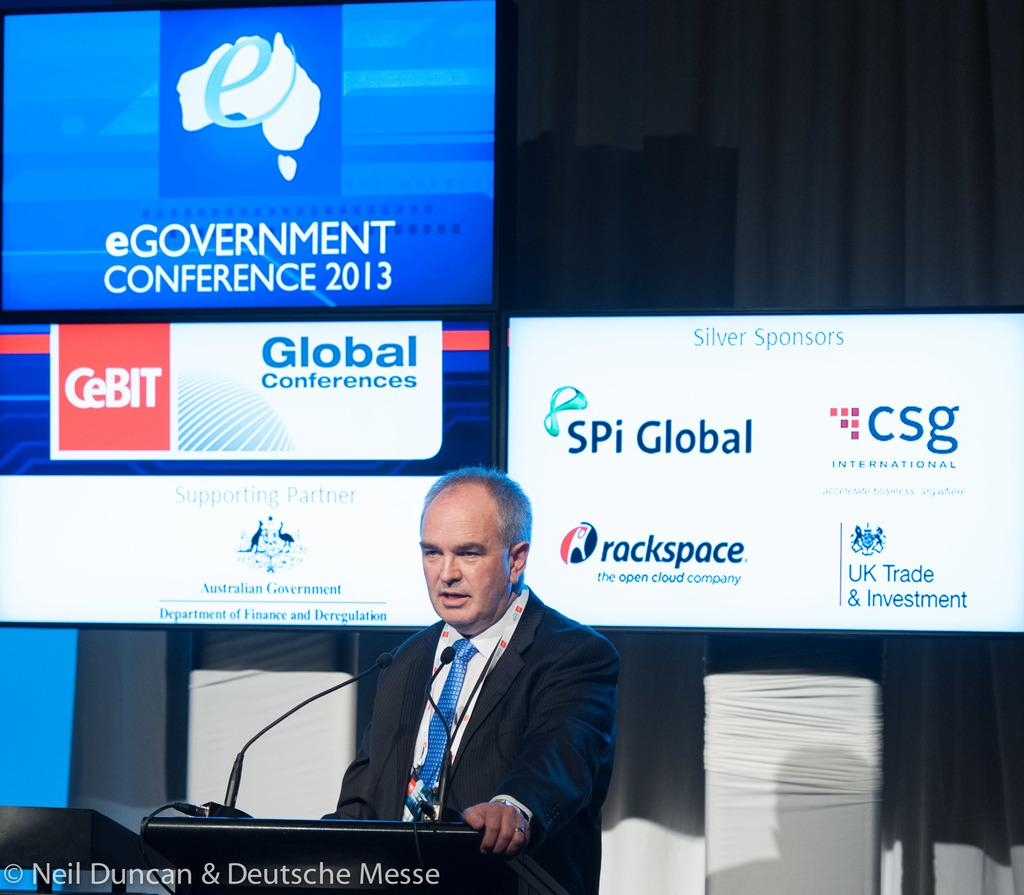<image>
Render a clear and concise summary of the photo. A man behind a lectern with a sign behind him that says eGovernment Conference 2013. 